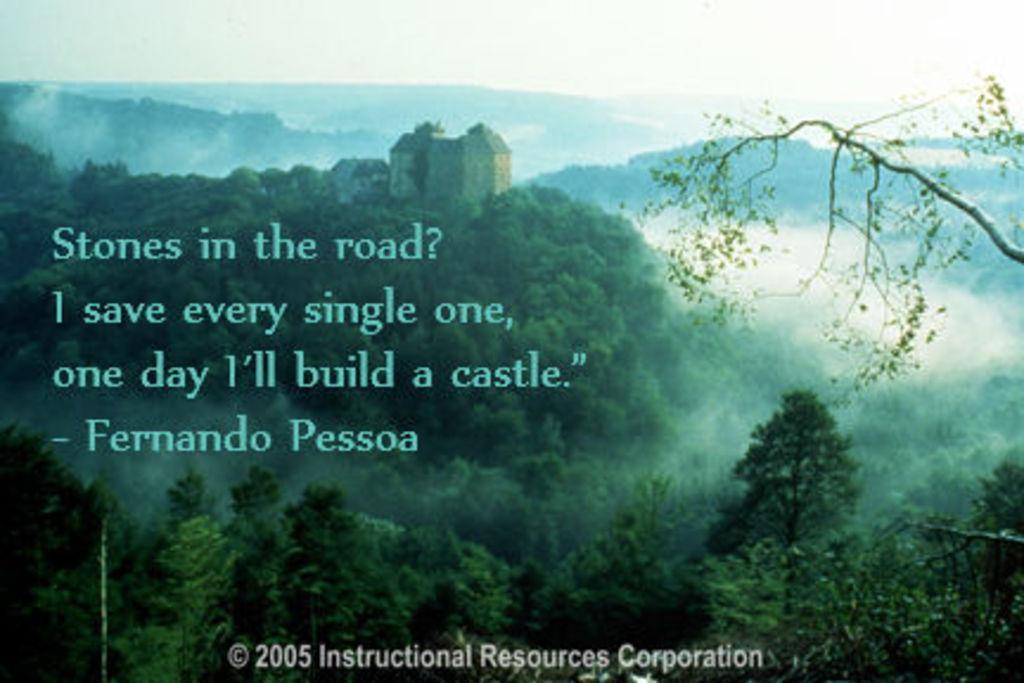Please provide a concise description of this image. In this image we can see a picture. In the picture there are ski, hills, buildings, trees and some text. 